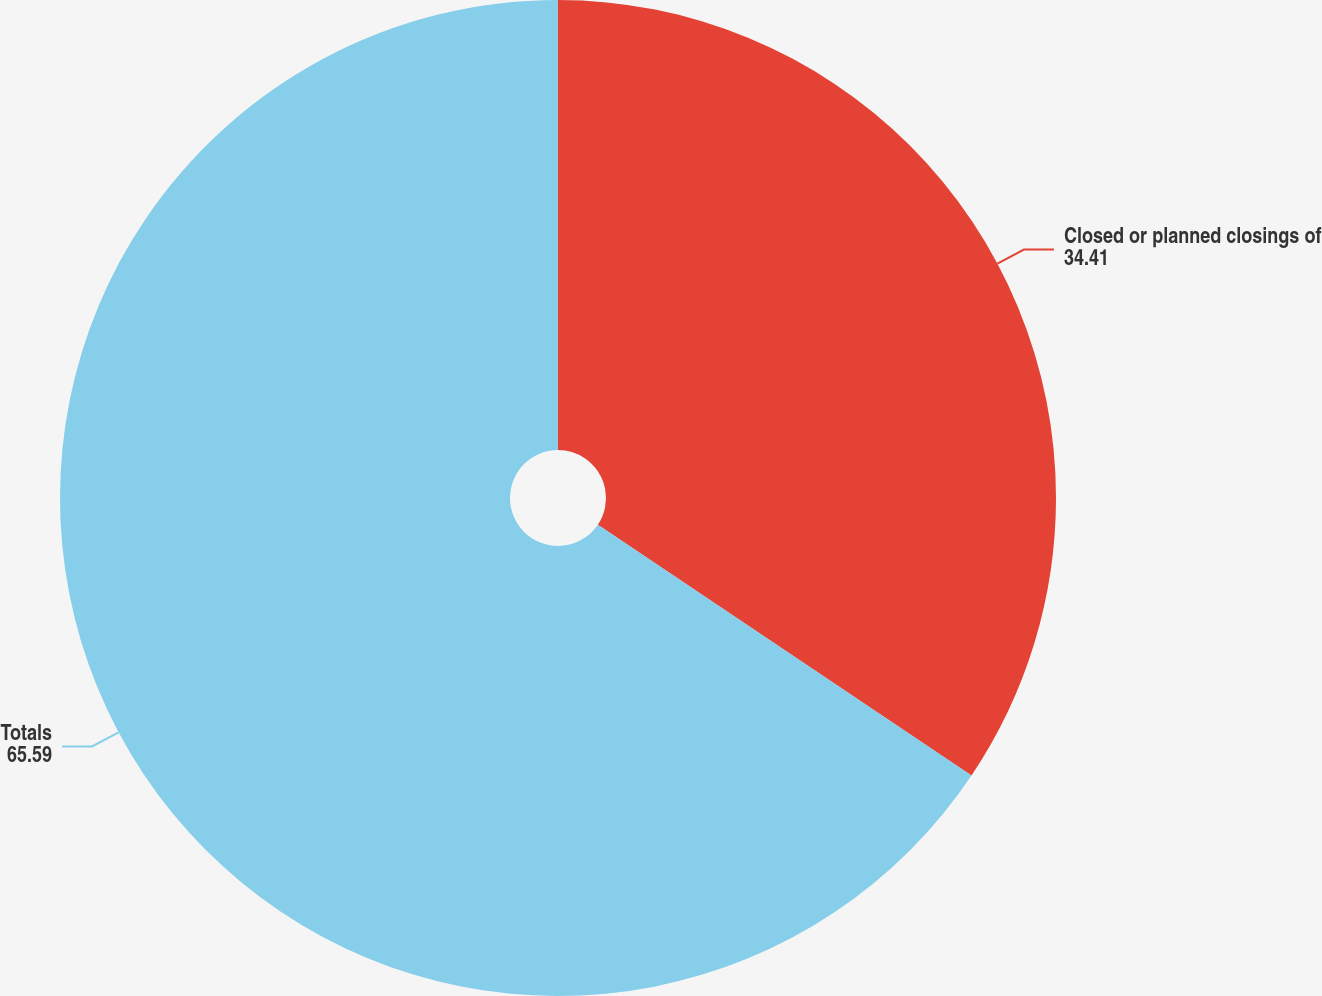Convert chart. <chart><loc_0><loc_0><loc_500><loc_500><pie_chart><fcel>Closed or planned closings of<fcel>Totals<nl><fcel>34.41%<fcel>65.59%<nl></chart> 